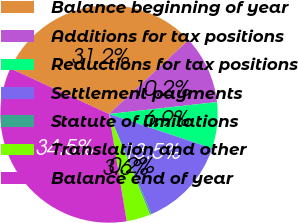<chart> <loc_0><loc_0><loc_500><loc_500><pie_chart><fcel>Balance beginning of year<fcel>Additions for tax positions<fcel>Reductions for tax positions<fcel>Settlement payments<fcel>Statute of limitations<fcel>Translation and other<fcel>Balance end of year<nl><fcel>31.17%<fcel>10.18%<fcel>6.87%<fcel>13.5%<fcel>0.23%<fcel>3.55%<fcel>34.49%<nl></chart> 